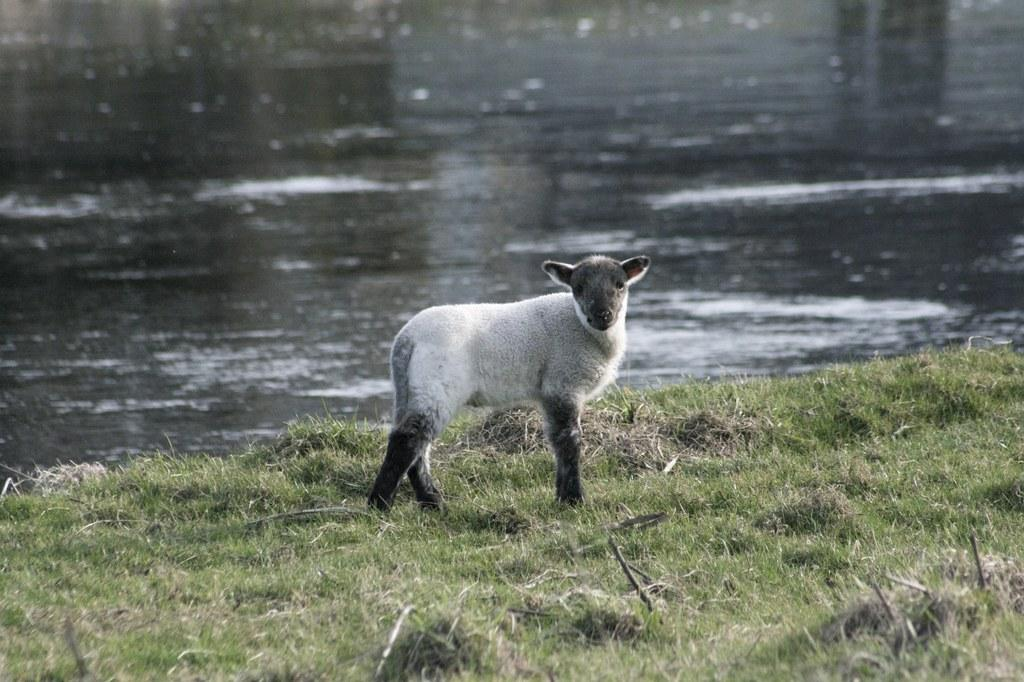What type of animal can be seen in the image? There is an animal in the image, but its specific type cannot be determined from the provided facts. Where is the animal located in the image? The animal is on the ground in the image. What type of vegetation is present on the ground? There is grass on the ground in the image. What can be seen in the background of the image? There is water visible in the background of the image. What is the purpose of the river in the image? There is no river present in the image, so it is not possible to determine its purpose. 